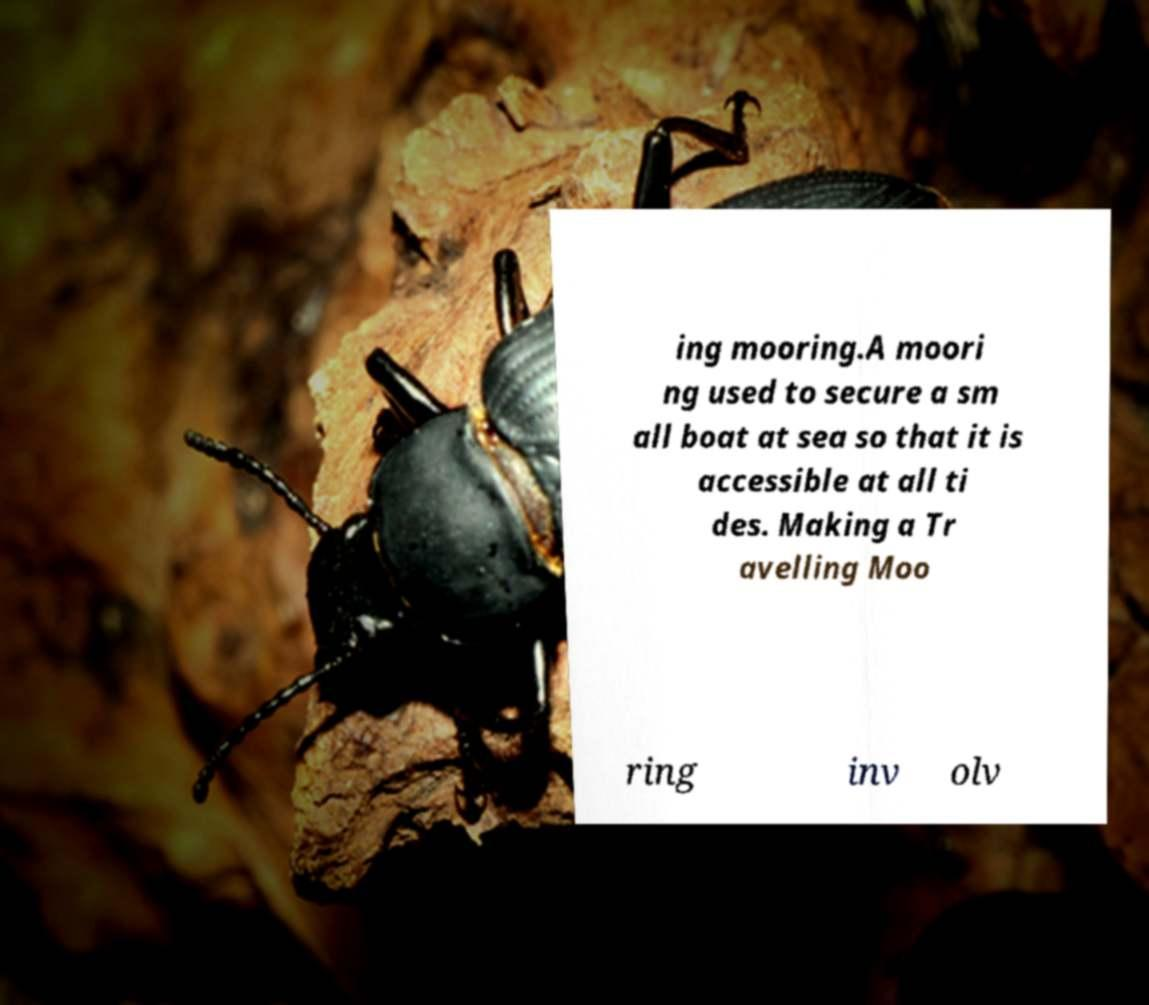Please read and relay the text visible in this image. What does it say? ing mooring.A moori ng used to secure a sm all boat at sea so that it is accessible at all ti des. Making a Tr avelling Moo ring inv olv 